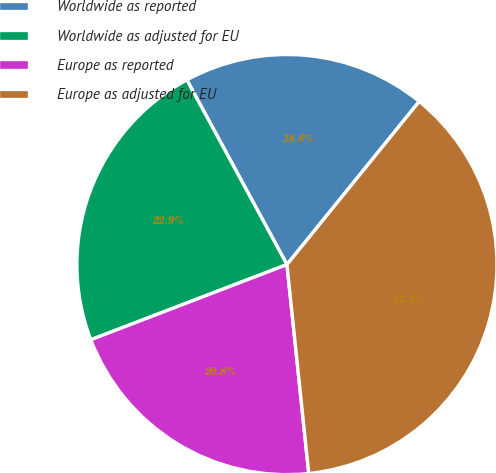Convert chart to OTSL. <chart><loc_0><loc_0><loc_500><loc_500><pie_chart><fcel>Worldwide as reported<fcel>Worldwide as adjusted for EU<fcel>Europe as reported<fcel>Europe as adjusted for EU<nl><fcel>18.75%<fcel>22.92%<fcel>20.83%<fcel>37.5%<nl></chart> 